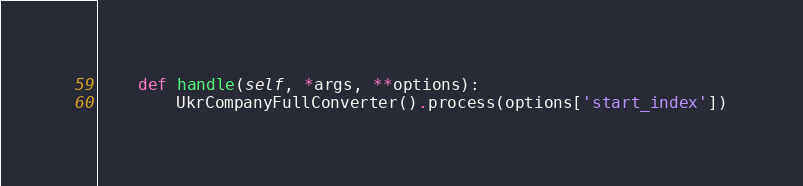<code> <loc_0><loc_0><loc_500><loc_500><_Python_>
    def handle(self, *args, **options):
        UkrCompanyFullConverter().process(options['start_index'])
</code> 